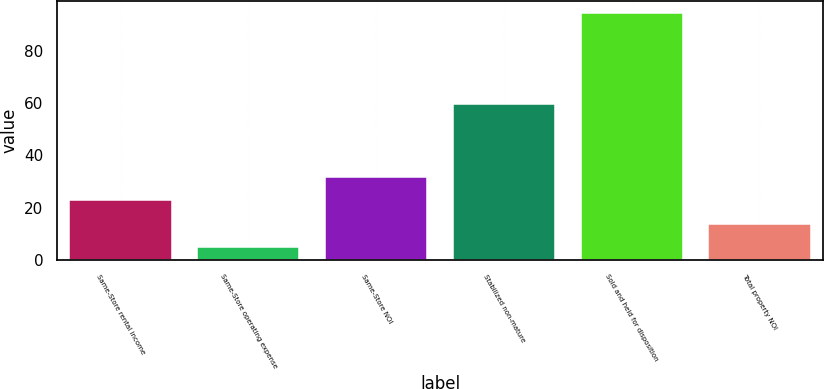Convert chart to OTSL. <chart><loc_0><loc_0><loc_500><loc_500><bar_chart><fcel>Same-Store rental income<fcel>Same-Store operating expense<fcel>Same-Store NOI<fcel>Stabilized non-mature<fcel>Sold and held for disposition<fcel>Total property NOI<nl><fcel>22.8<fcel>4.9<fcel>31.75<fcel>59.7<fcel>94.4<fcel>13.85<nl></chart> 